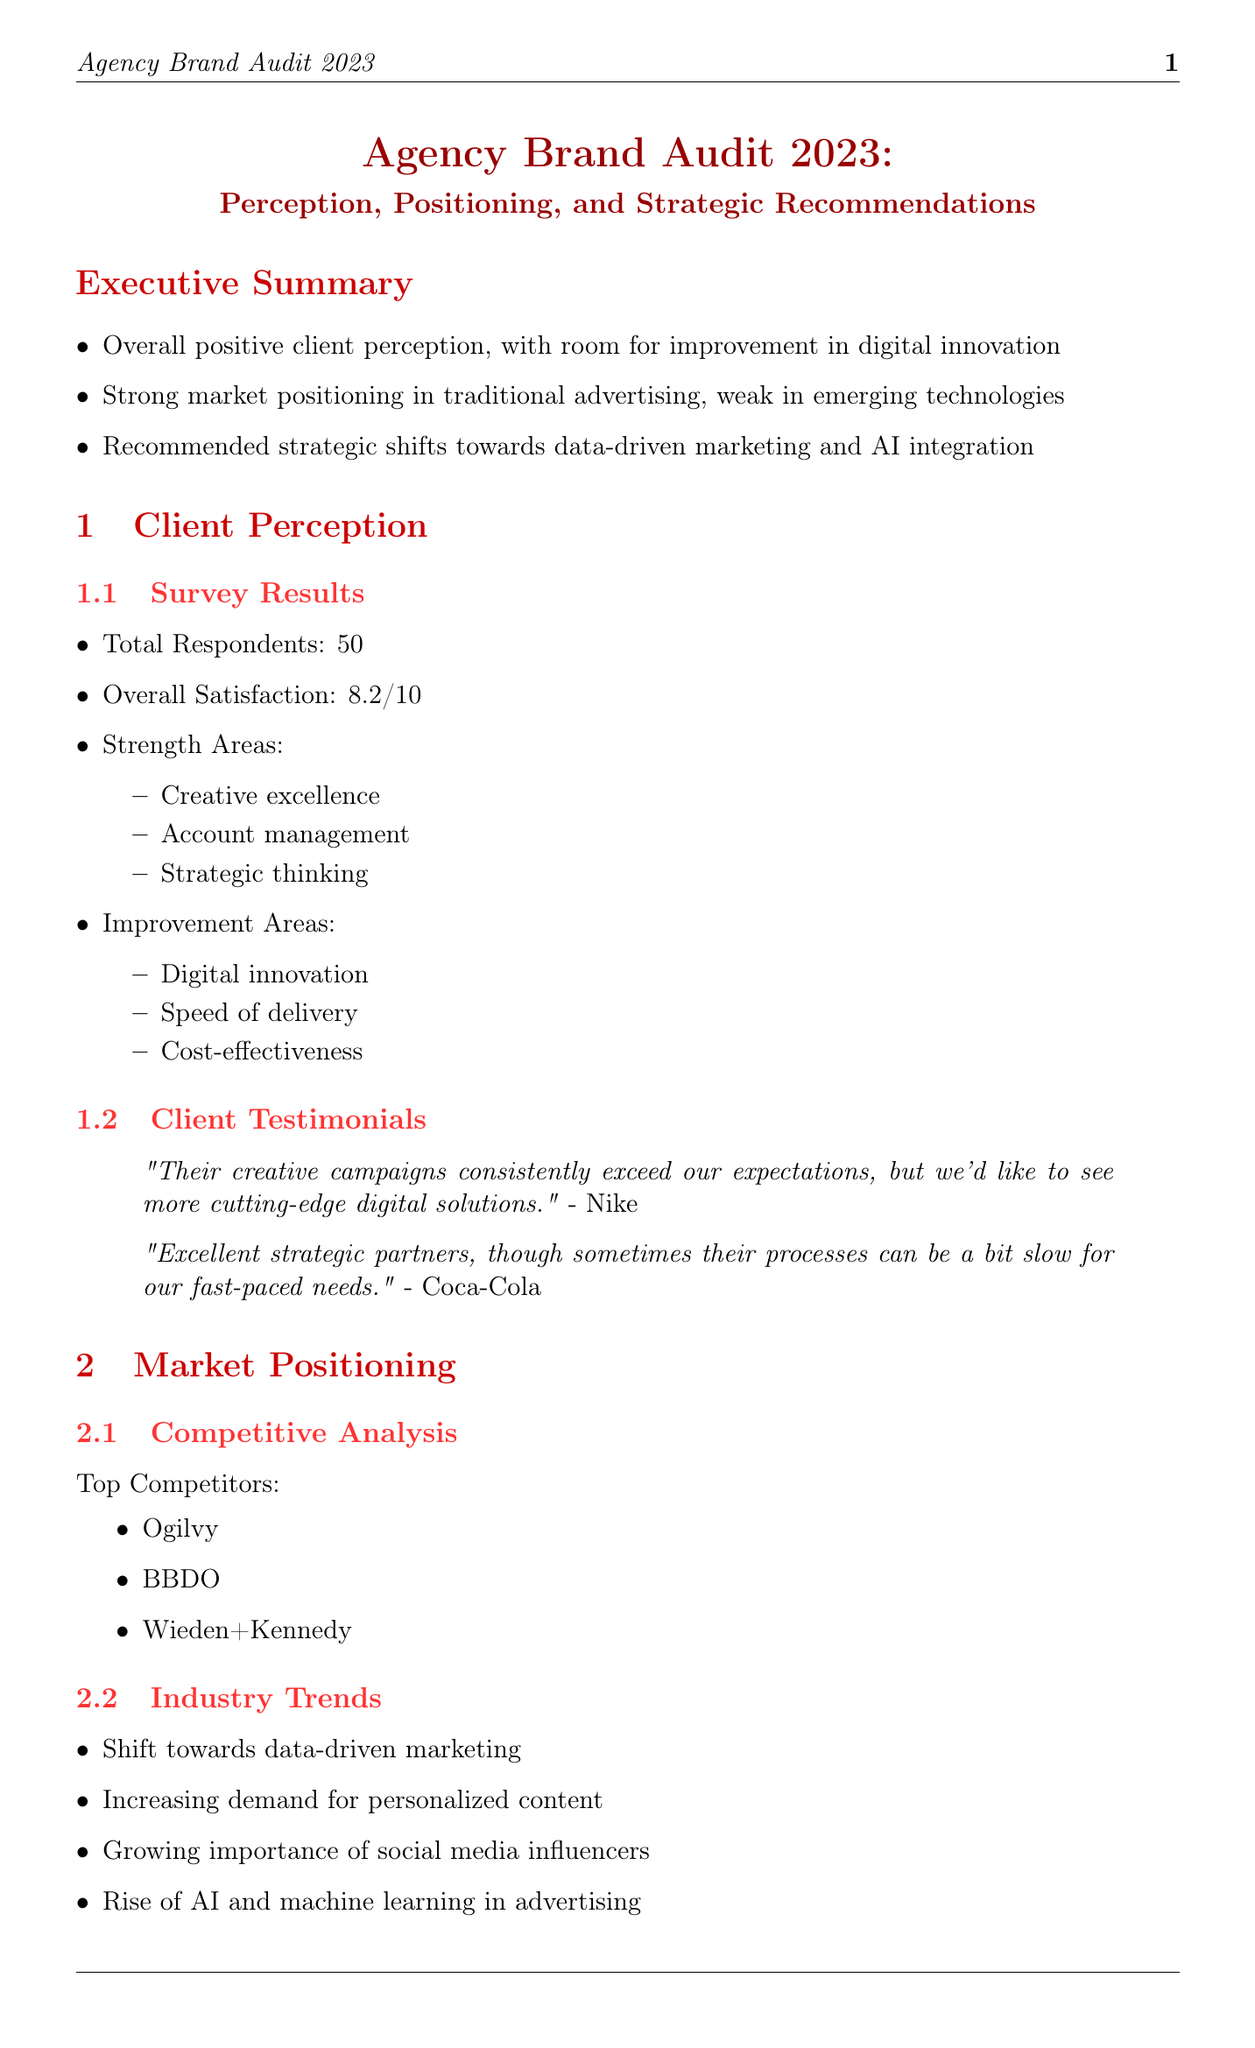what is the overall client satisfaction score? The overall satisfaction score reported in the survey results is an important indicator of client perception.
Answer: 8.2 what are the strength areas identified in client perception? Strength areas are specific aspects where the agency excels, highlighting its capabilities and performance.
Answer: Creative excellence, Account management, Strategic thinking which area is recommended for improvement? The improvement areas suggest where the agency can enhance its services to meet client demands more effectively.
Answer: Digital innovation who are the top competitors listed in the market positioning section? Identifying competitors is crucial for understanding the agency's position in the market compared to others.
Answer: Ogilvy, BBDO, Wieden+Kennedy what is the first recommended strategic shift? The recommended strategic shifts outline actionable changes the agency should consider for future growth and effectiveness.
Answer: Digital Innovation what percentage of the annual budget should be allocated to R&D? This percentage indicates the commitment to investing in new technologies and innovations within the agency's overall financial planning.
Answer: 15% what is the main focus of the agency's conclusion? The conclusion summarizes the essential findings and recommendations of the audit report, emphasizing key priorities for the agency's future.
Answer: Adapt to the rapidly changing digital landscape what methodology was used for research? The research methodology provides insight into the approach and data sources utilized in the audit, ensuring credibility and relevance.
Answer: Combination of online surveys, in-depth client interviews, and industry analysis 